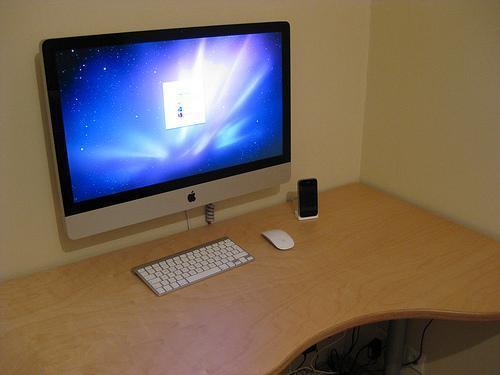How many mouse on the table?
Give a very brief answer. 1. 